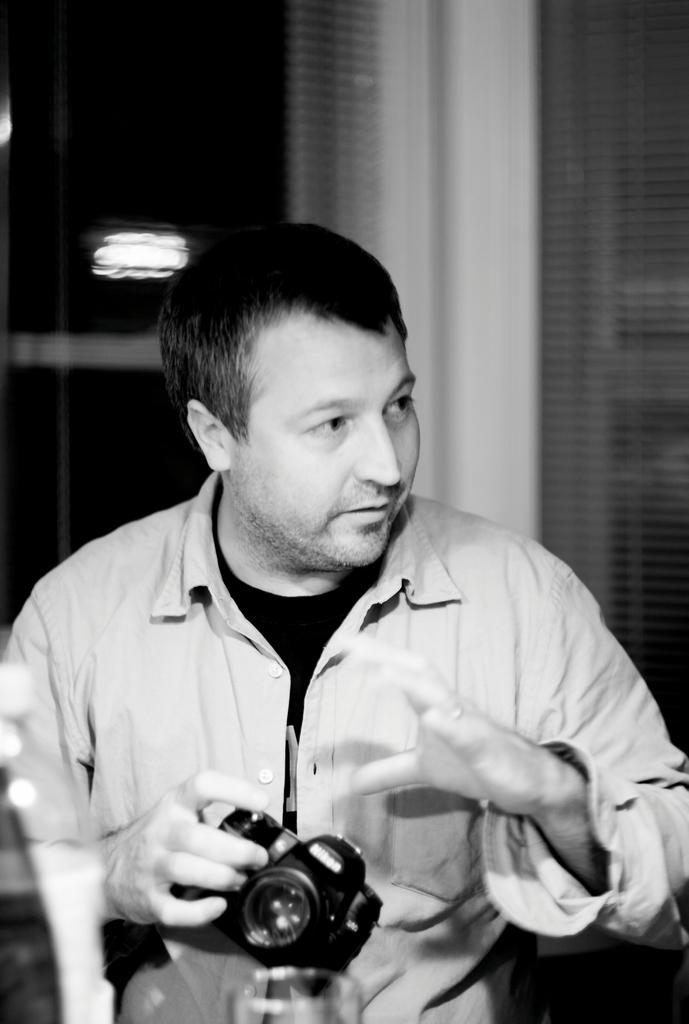How would you summarize this image in a sentence or two? In the middle of the image a man is standing and holding a camera. Bottom left side of the image there is a water bottle. Top left side of the image there is a light. 